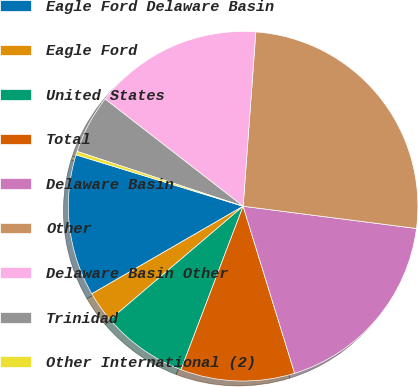Convert chart to OTSL. <chart><loc_0><loc_0><loc_500><loc_500><pie_chart><fcel>Eagle Ford Delaware Basin<fcel>Eagle Ford<fcel>United States<fcel>Total<fcel>Delaware Basin<fcel>Other<fcel>Delaware Basin Other<fcel>Trinidad<fcel>Other International (2)<nl><fcel>13.1%<fcel>2.88%<fcel>7.99%<fcel>10.54%<fcel>18.21%<fcel>25.87%<fcel>15.65%<fcel>5.43%<fcel>0.33%<nl></chart> 